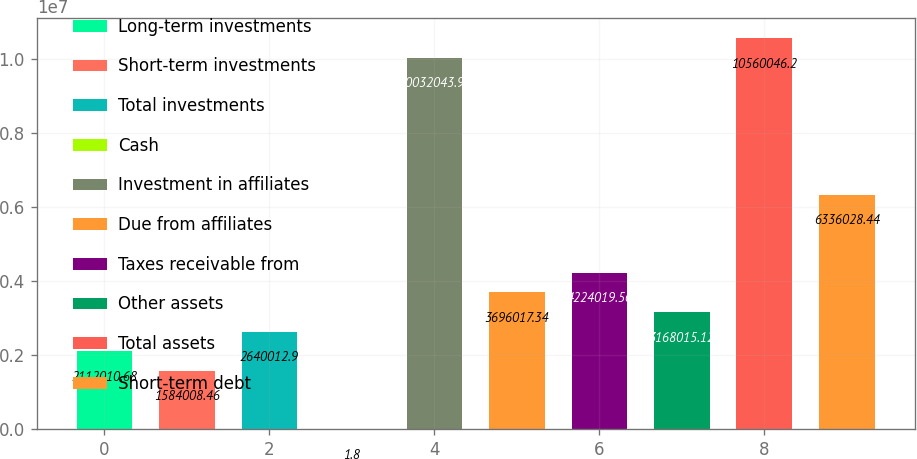Convert chart. <chart><loc_0><loc_0><loc_500><loc_500><bar_chart><fcel>Long-term investments<fcel>Short-term investments<fcel>Total investments<fcel>Cash<fcel>Investment in affiliates<fcel>Due from affiliates<fcel>Taxes receivable from<fcel>Other assets<fcel>Total assets<fcel>Short-term debt<nl><fcel>2.11201e+06<fcel>1.58401e+06<fcel>2.64001e+06<fcel>1.8<fcel>1.0032e+07<fcel>3.69602e+06<fcel>4.22402e+06<fcel>3.16802e+06<fcel>1.056e+07<fcel>6.33603e+06<nl></chart> 